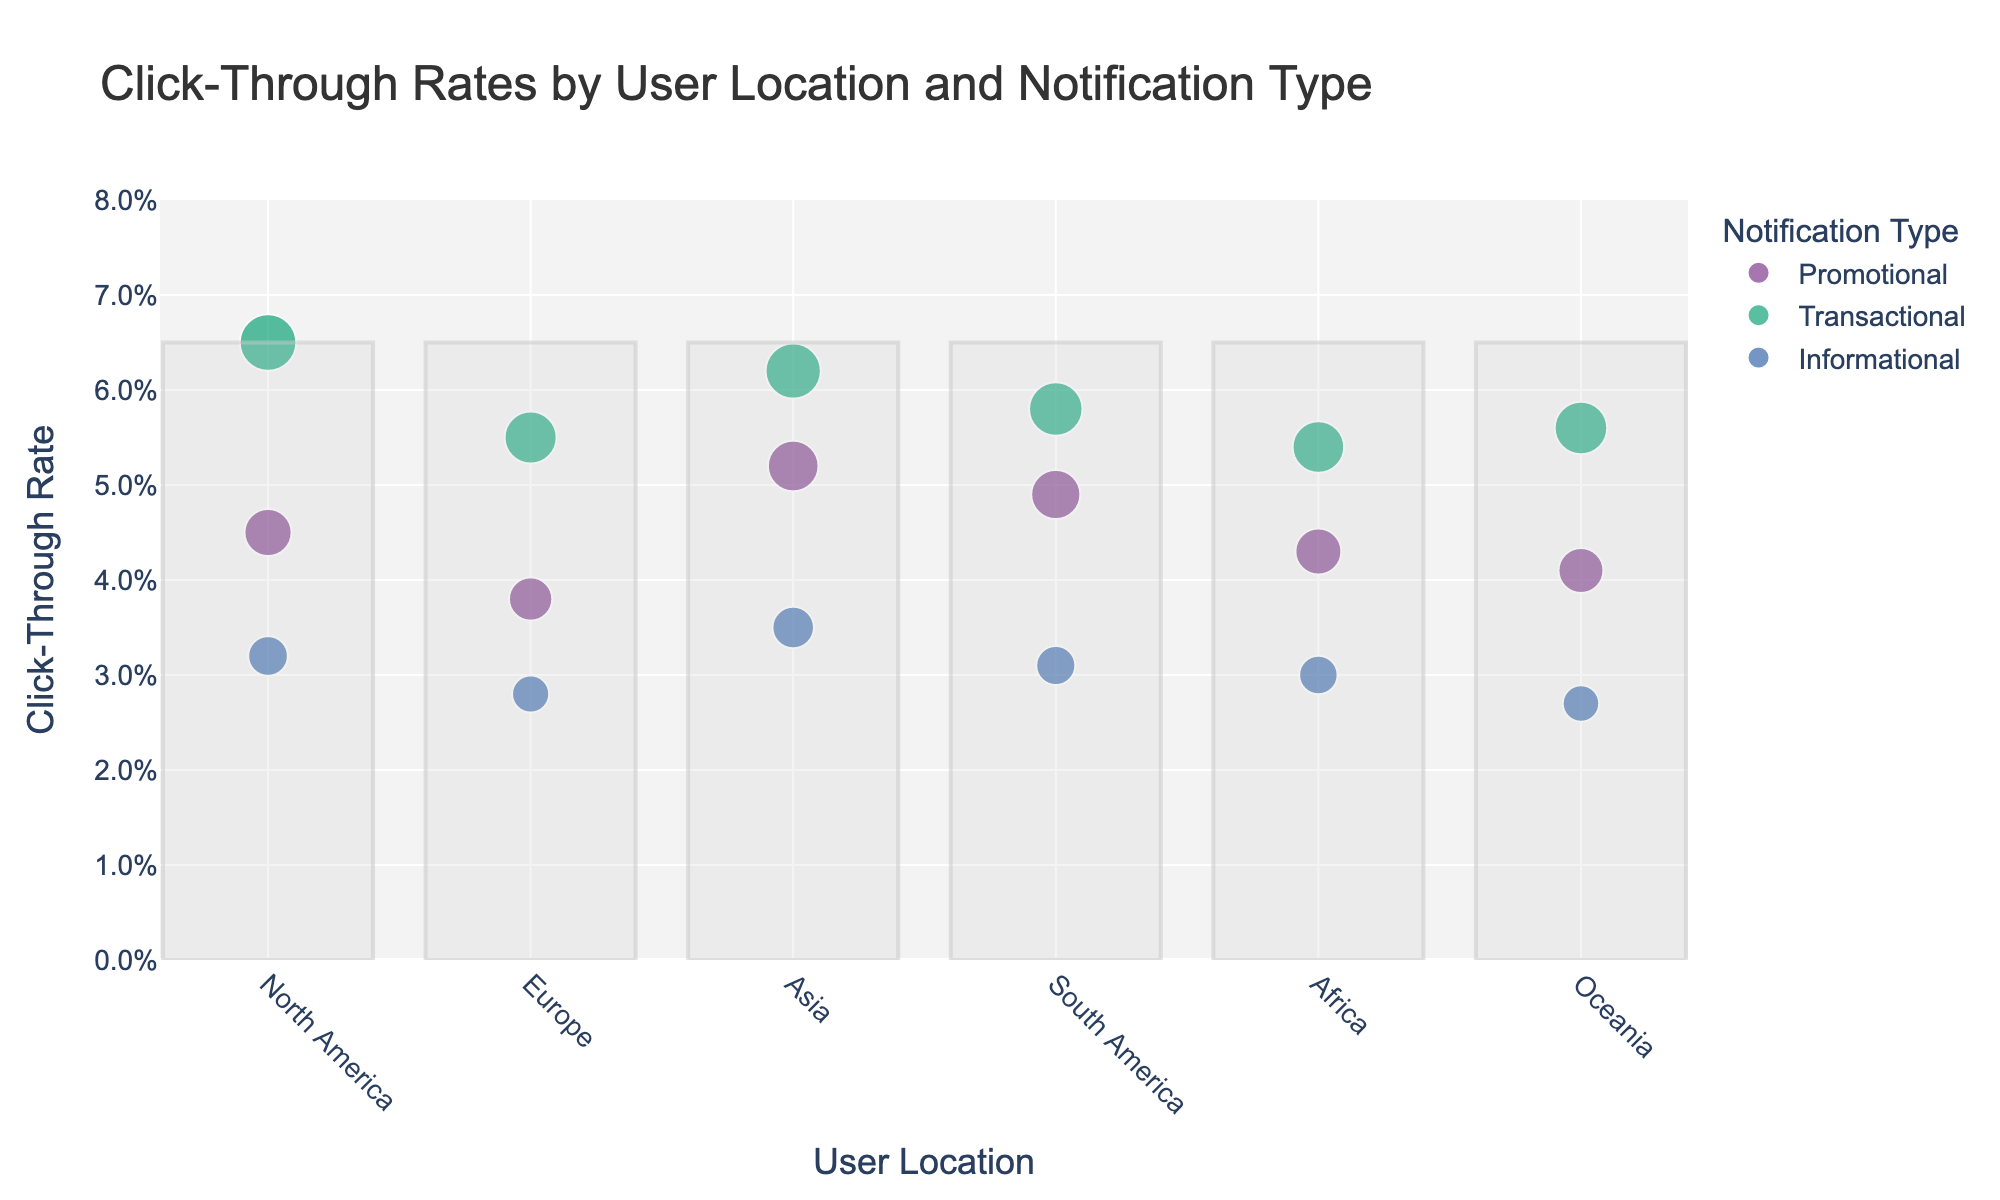What is the title of the figure? The title is usually displayed at the top of the figure and provides a quick summary of what the graph is about. Here, it gives insight about what data the scatter plot represents.
Answer: Click-Through Rates by User Location and Notification Type Which user location has the highest click-through rate for promotional notifications? To find the user location with the highest click-through rate for promotional notifications, look at the points in the promotional category and identify the one with the highest position on the y-axis.
Answer: Asia What is the click-through rate for transactional notifications in Europe? Locate the point corresponding to transactional notifications in Europe on the scatter plot. The y-coordinate of this point will give the required click-through rate.
Answer: 0.055 Compare the click-through rates for informational notifications between North America and Europe. Which is higher, and by how much? Identify the click-through rates for informational notifications in both North America and Europe. Subtract the smaller value from the larger value to get the difference.
Answer: North America is higher by 0.004 Which type of notification has the lowest overall click-through rate in Oceania? Look at the points corresponding to different types of notifications in Oceania and find the one with the lowest y-coordinate value.
Answer: Informational What is the average click-through rate for transactional notifications across all user locations? Sum the click-through rates for transactional notifications across all user locations, and then divide by the number of such data points (6).
Answer: 0.058 Are there any user locations where the click-through rate for promotional notifications is higher than for transactional notifications? Compare the click-through rates of promotional and transactional notifications for each user location to see if there is any location where the promotional rate is higher.
Answer: No Which user location shows the smallest difference in click-through rates between promotional and informational notifications? For each user location, subtract the click-through rate of informational notifications from that of promotional notifications, and find the smallest difference.
Answer: North America What is the total number of data points represented in this scatter plot? Count the number of user locations and multiply by the number of notification types to find the total number of data points in the scatter plot.
Answer: 18 How does the click-through rate for transactional notifications in Asia compare to the click-through rate for promotional notifications in South America? Locate both data points on the scatter plot and compare their y-coordinate values.
Answer: Asia's transactional rate is higher by 0.004 